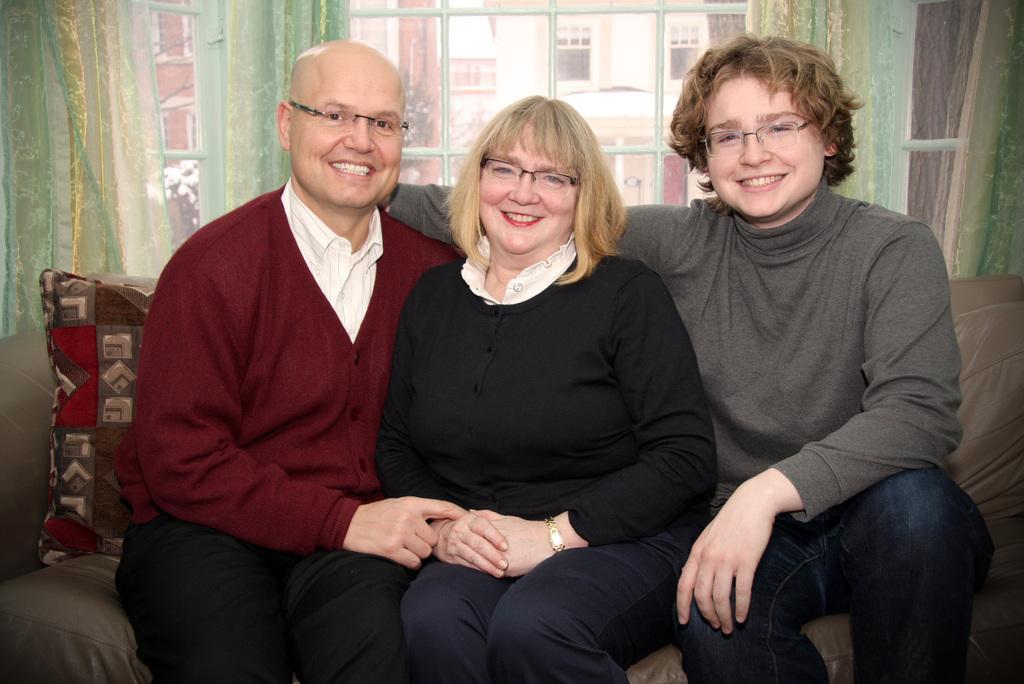How would you summarize this image in a sentence or two? In this image we can see three persons, two men and a woman sitting on couch and in the background of the image there is window, curtain through which we can see some buildings. 